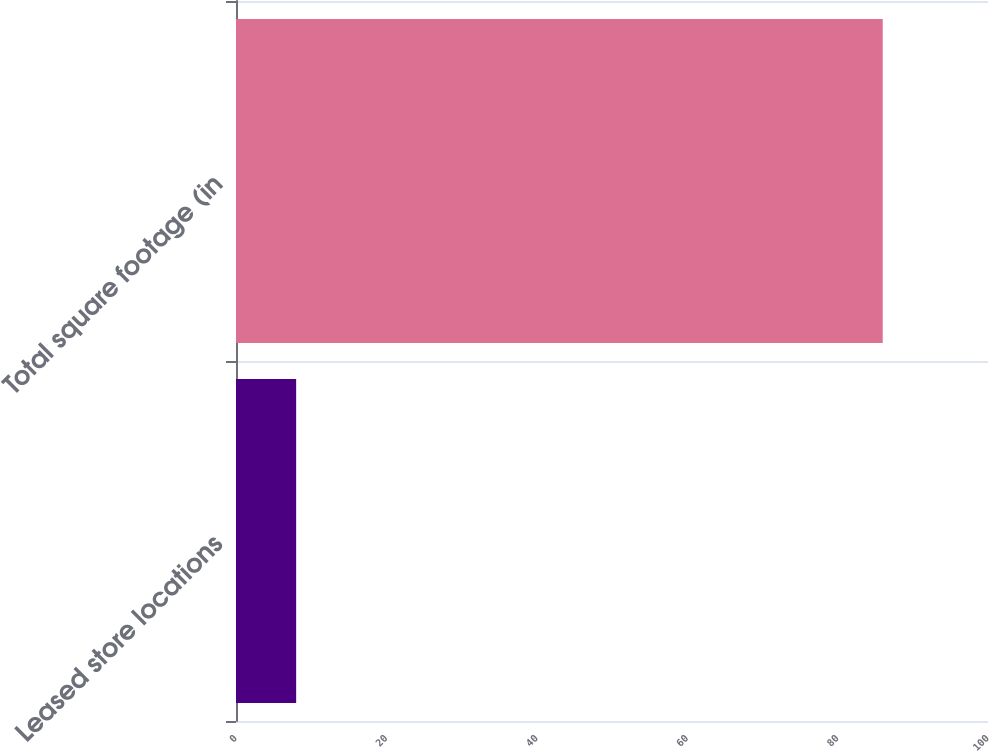Convert chart. <chart><loc_0><loc_0><loc_500><loc_500><bar_chart><fcel>Leased store locations<fcel>Total square footage (in<nl><fcel>8<fcel>86<nl></chart> 